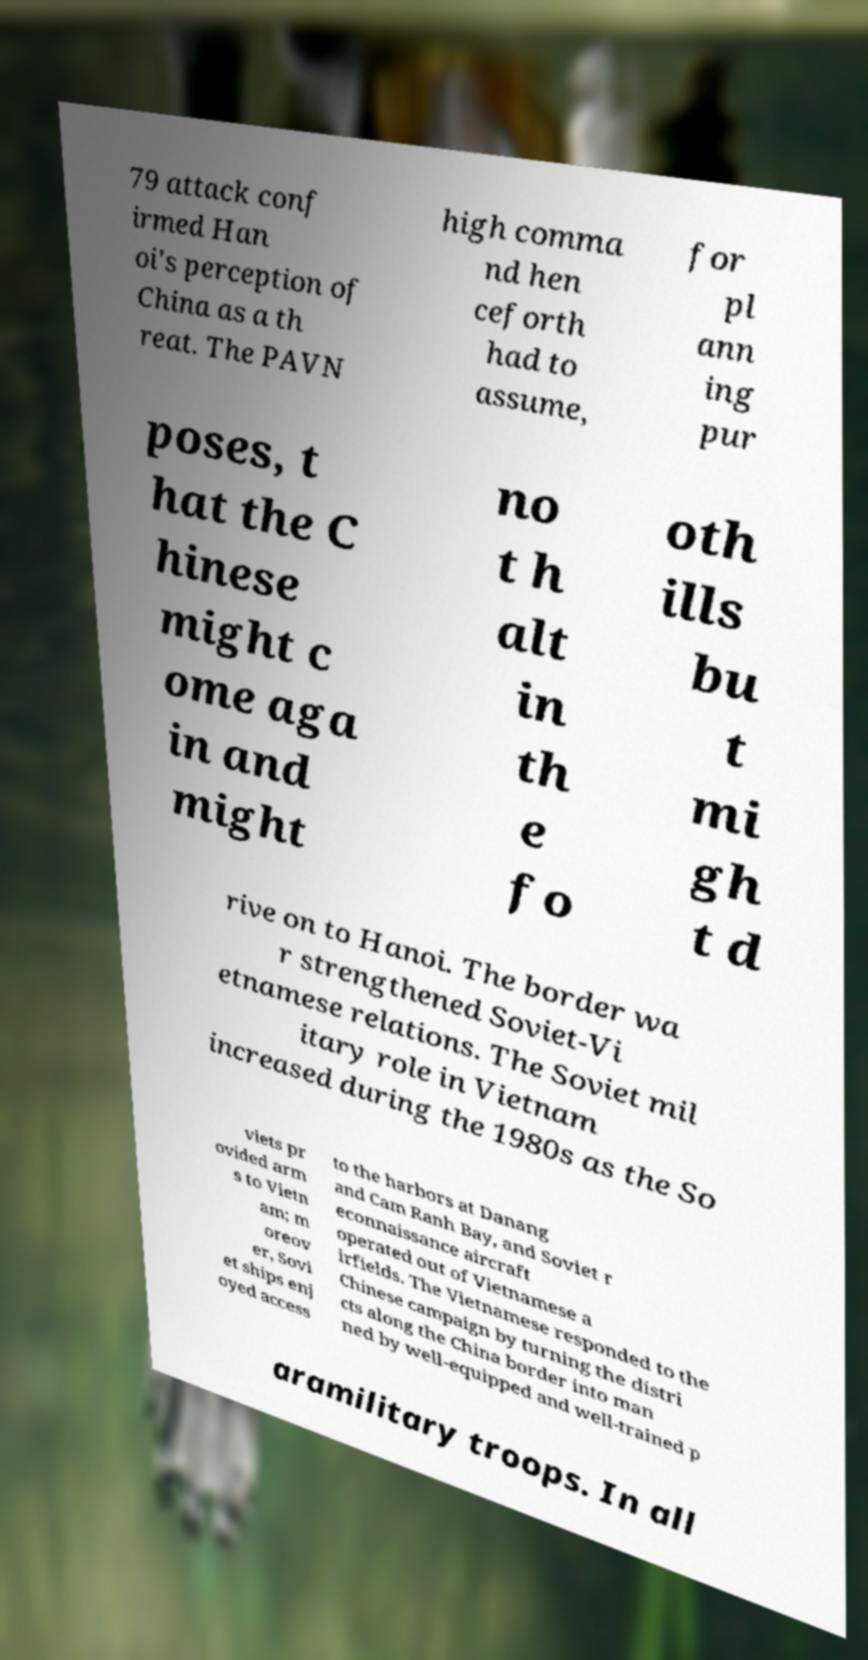Can you read and provide the text displayed in the image?This photo seems to have some interesting text. Can you extract and type it out for me? 79 attack conf irmed Han oi's perception of China as a th reat. The PAVN high comma nd hen ceforth had to assume, for pl ann ing pur poses, t hat the C hinese might c ome aga in and might no t h alt in th e fo oth ills bu t mi gh t d rive on to Hanoi. The border wa r strengthened Soviet-Vi etnamese relations. The Soviet mil itary role in Vietnam increased during the 1980s as the So viets pr ovided arm s to Vietn am; m oreov er, Sovi et ships enj oyed access to the harbors at Danang and Cam Ranh Bay, and Soviet r econnaissance aircraft operated out of Vietnamese a irfields. The Vietnamese responded to the Chinese campaign by turning the distri cts along the China border into man ned by well-equipped and well-trained p aramilitary troops. In all 